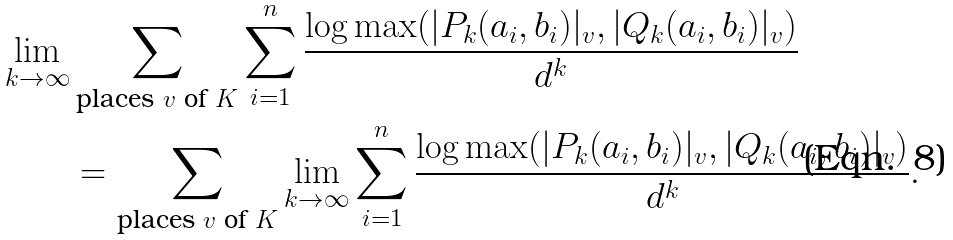<formula> <loc_0><loc_0><loc_500><loc_500>\lim _ { k \to \infty } & \sum _ { \text {places $v$ of $K$} } \sum _ { i = 1 } ^ { n } \frac { \log \max ( | P _ { k } ( a _ { i } , b _ { i } ) | _ { v } , | Q _ { k } ( a _ { i } , b _ { i } ) | _ { v } ) } { d ^ { k } } \\ & = \sum _ { \text {places $v$ of $K$} } \lim _ { k \to \infty } \sum _ { i = 1 } ^ { n } \frac { \log \max ( | P _ { k } ( a _ { i } , b _ { i } ) | _ { v } , | Q _ { k } ( a _ { i } , b _ { i } ) | _ { v } ) } { d ^ { k } } .</formula> 